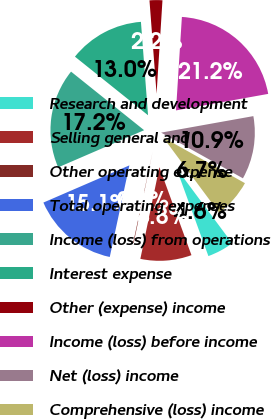<chart> <loc_0><loc_0><loc_500><loc_500><pie_chart><fcel>Research and development<fcel>Selling general and<fcel>Other operating expense<fcel>Total operating expenses<fcel>Income (loss) from operations<fcel>Interest expense<fcel>Other (expense) income<fcel>Income (loss) before income<fcel>Net (loss) income<fcel>Comprehensive (loss) income<nl><fcel>4.61%<fcel>8.82%<fcel>0.1%<fcel>15.15%<fcel>17.25%<fcel>13.04%<fcel>2.21%<fcel>21.18%<fcel>10.93%<fcel>6.72%<nl></chart> 